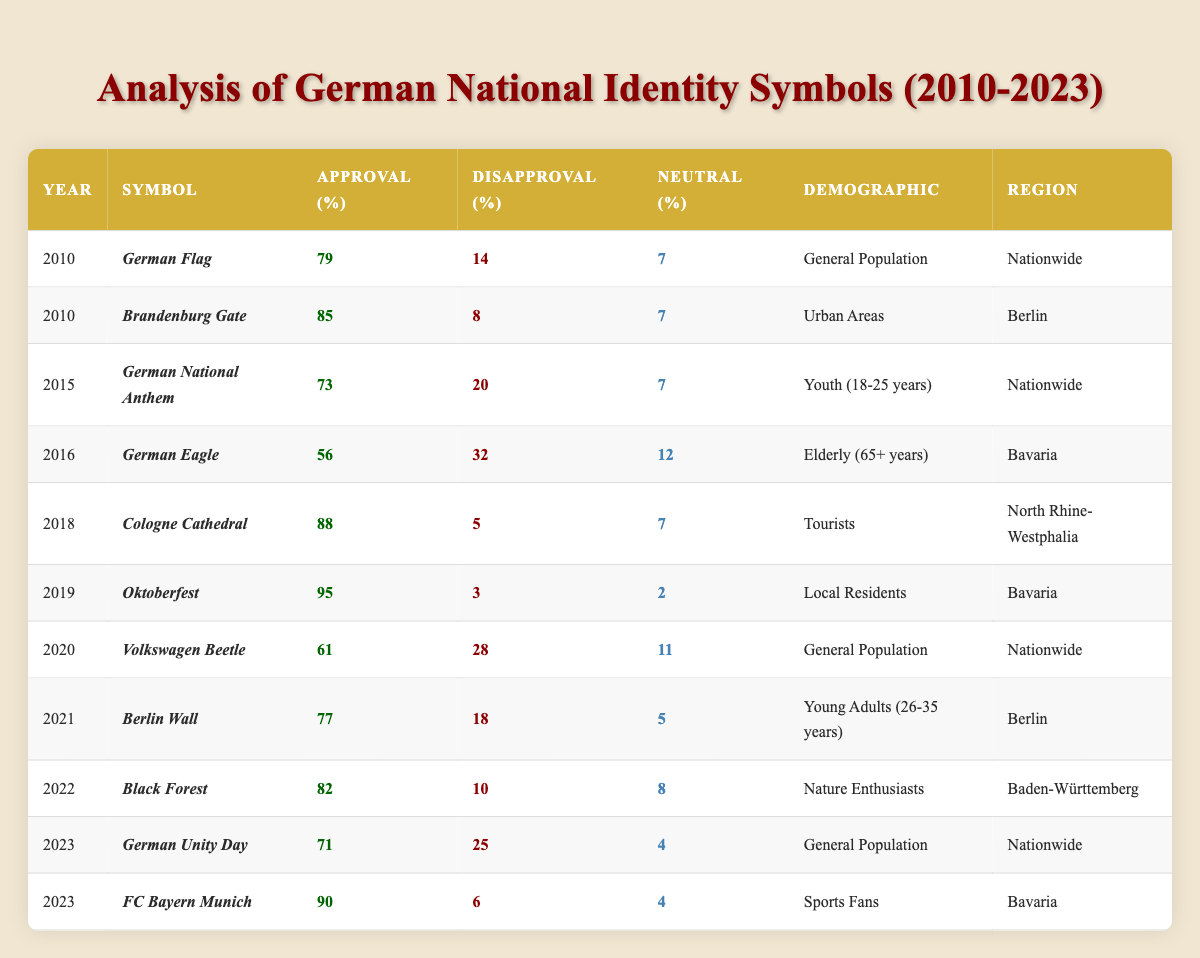What was the approval rating for the German Flag in 2010? According to the table, the approval rating for the German Flag in 2010 is listed as 79%.
Answer: 79% Which symbol had the highest approval rating in 2019? The table indicates that Oktoberfest had the highest approval rating in 2019 at 95%.
Answer: 95% What is the disapproval rating for the Black Forest among Nature Enthusiasts in 2022? From the table, the disapproval rating for the Black Forest in 2022 is 10%.
Answer: 10% How does the approval rating of the German Eagle in 2016 compare to the German National Anthem in 2015? The approval rating for the German Eagle in 2016 is 56%, while for the German National Anthem in 2015 it is 73%. The German National Anthem has a higher approval rating by 17%.
Answer: 17% What was the overall trend in approval ratings for symbols between 2010 and 2023? Reviewing the data, the approval ratings are mixed; however, notable symbols like FC Bayern Munich in 2023 have high approval (90%), while symbols like German Eagle have shown low ratings in earlier years. Overall, certain symbols have increased in popularity.
Answer: Mixed trend, with some symbols increasing in approval Which demographic showed the lowest approval rating for a national identity symbol, and what was that rating? The table shows that the German Eagle had the lowest approval rating at 56% among the elderly (65+ years) in 2016.
Answer: Elderly, 56% Calculate the average approval rating for the symbols in 2023. The approval ratings for symbols in 2023 are 71% (German Unity Day) and 90% (FC Bayern Munich). Their sum is 71 + 90 = 161, and the average is 161 / 2 = 80.5%.
Answer: 80.5% Is the approval rating for the Cologne Cathedral higher or lower than that of the Volkswagen Beetle in 2020? The approval rating for the Cologne Cathedral in 2018 is 88%, while the Volkswagen Beetle has an approval rating of 61% in 2020. Therefore, the Cologne Cathedral has a higher rating.
Answer: Higher What symbol received the lowest disapproval rating among all the entries? The table indicates that Oktoberfest had the lowest disapproval rating at 3%.
Answer: 3% Did approval ratings for the German Unity Day change significantly more than the German Flag from 2010 to 2023? The approval for the German Flag was 79% in 2010 and 71% in 2023, showing a decrease of 8%. German Unity Day rated 71% in 2023; hence, the change is based on only one year and is not as significant as fluctuations seen in other symbols over time.
Answer: No, not significantly How many years showed a neutral rating of 7% for any symbol? By checking the table, both the German Flag from 2010 and the German National Anthem from 2015 show a neutral rating of 7%. This happened in 2 different years.
Answer: 2 years 